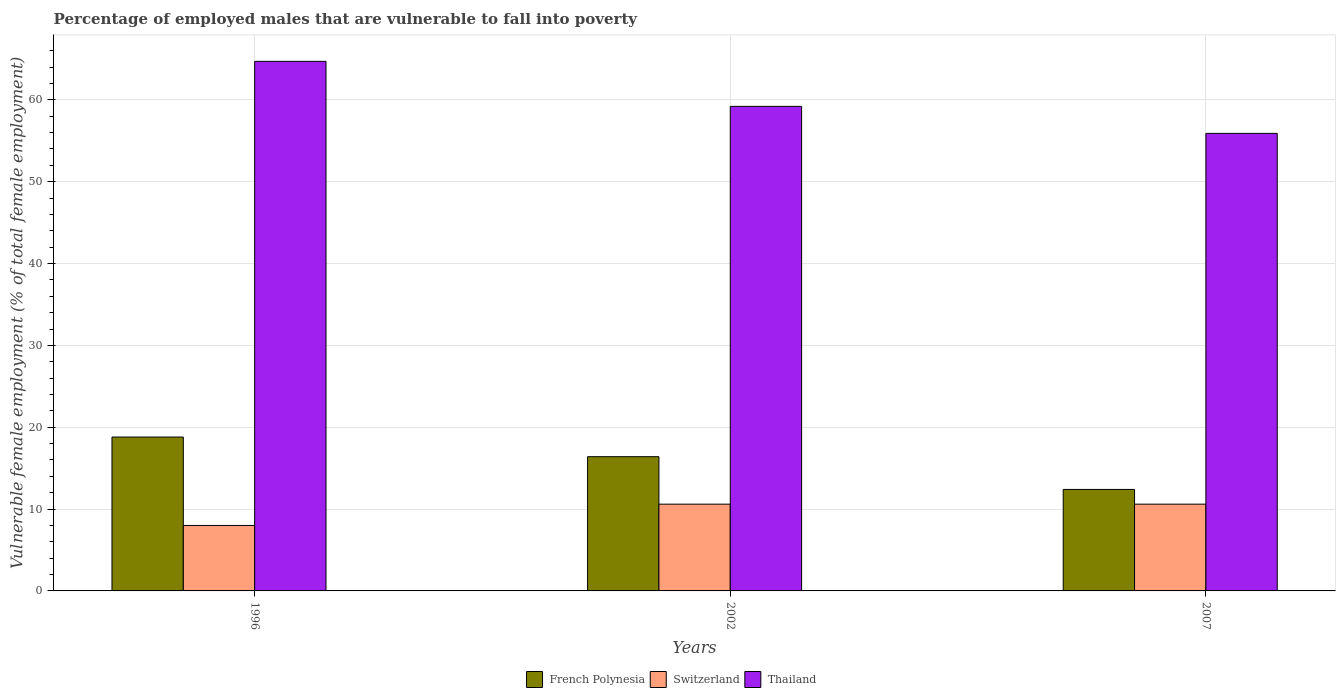How many different coloured bars are there?
Your answer should be very brief. 3. How many bars are there on the 3rd tick from the left?
Offer a very short reply. 3. What is the percentage of employed males who are vulnerable to fall into poverty in French Polynesia in 2002?
Provide a short and direct response. 16.4. Across all years, what is the maximum percentage of employed males who are vulnerable to fall into poverty in Thailand?
Your answer should be very brief. 64.7. Across all years, what is the minimum percentage of employed males who are vulnerable to fall into poverty in French Polynesia?
Your answer should be very brief. 12.4. In which year was the percentage of employed males who are vulnerable to fall into poverty in Thailand maximum?
Provide a succinct answer. 1996. In which year was the percentage of employed males who are vulnerable to fall into poverty in Thailand minimum?
Your answer should be compact. 2007. What is the total percentage of employed males who are vulnerable to fall into poverty in Switzerland in the graph?
Ensure brevity in your answer.  29.2. What is the difference between the percentage of employed males who are vulnerable to fall into poverty in French Polynesia in 1996 and that in 2002?
Make the answer very short. 2.4. What is the difference between the percentage of employed males who are vulnerable to fall into poverty in Switzerland in 2007 and the percentage of employed males who are vulnerable to fall into poverty in French Polynesia in 2002?
Offer a terse response. -5.8. What is the average percentage of employed males who are vulnerable to fall into poverty in Switzerland per year?
Offer a terse response. 9.73. In the year 1996, what is the difference between the percentage of employed males who are vulnerable to fall into poverty in Thailand and percentage of employed males who are vulnerable to fall into poverty in French Polynesia?
Make the answer very short. 45.9. In how many years, is the percentage of employed males who are vulnerable to fall into poverty in Switzerland greater than 52 %?
Offer a terse response. 0. What is the ratio of the percentage of employed males who are vulnerable to fall into poverty in French Polynesia in 1996 to that in 2002?
Provide a short and direct response. 1.15. Is the percentage of employed males who are vulnerable to fall into poverty in Thailand in 1996 less than that in 2007?
Provide a succinct answer. No. Is the difference between the percentage of employed males who are vulnerable to fall into poverty in Thailand in 1996 and 2007 greater than the difference between the percentage of employed males who are vulnerable to fall into poverty in French Polynesia in 1996 and 2007?
Offer a very short reply. Yes. What is the difference between the highest and the second highest percentage of employed males who are vulnerable to fall into poverty in Switzerland?
Make the answer very short. 0. What is the difference between the highest and the lowest percentage of employed males who are vulnerable to fall into poverty in French Polynesia?
Provide a succinct answer. 6.4. In how many years, is the percentage of employed males who are vulnerable to fall into poverty in Thailand greater than the average percentage of employed males who are vulnerable to fall into poverty in Thailand taken over all years?
Provide a short and direct response. 1. What does the 1st bar from the left in 2007 represents?
Your response must be concise. French Polynesia. What does the 3rd bar from the right in 1996 represents?
Give a very brief answer. French Polynesia. Does the graph contain any zero values?
Offer a terse response. No. Does the graph contain grids?
Give a very brief answer. Yes. How many legend labels are there?
Your response must be concise. 3. How are the legend labels stacked?
Offer a very short reply. Horizontal. What is the title of the graph?
Give a very brief answer. Percentage of employed males that are vulnerable to fall into poverty. Does "Bahrain" appear as one of the legend labels in the graph?
Your response must be concise. No. What is the label or title of the X-axis?
Ensure brevity in your answer.  Years. What is the label or title of the Y-axis?
Keep it short and to the point. Vulnerable female employment (% of total female employment). What is the Vulnerable female employment (% of total female employment) in French Polynesia in 1996?
Offer a terse response. 18.8. What is the Vulnerable female employment (% of total female employment) of Switzerland in 1996?
Offer a terse response. 8. What is the Vulnerable female employment (% of total female employment) of Thailand in 1996?
Provide a succinct answer. 64.7. What is the Vulnerable female employment (% of total female employment) in French Polynesia in 2002?
Provide a succinct answer. 16.4. What is the Vulnerable female employment (% of total female employment) of Switzerland in 2002?
Your answer should be very brief. 10.6. What is the Vulnerable female employment (% of total female employment) of Thailand in 2002?
Provide a short and direct response. 59.2. What is the Vulnerable female employment (% of total female employment) of French Polynesia in 2007?
Make the answer very short. 12.4. What is the Vulnerable female employment (% of total female employment) in Switzerland in 2007?
Give a very brief answer. 10.6. What is the Vulnerable female employment (% of total female employment) of Thailand in 2007?
Offer a very short reply. 55.9. Across all years, what is the maximum Vulnerable female employment (% of total female employment) of French Polynesia?
Keep it short and to the point. 18.8. Across all years, what is the maximum Vulnerable female employment (% of total female employment) of Switzerland?
Provide a succinct answer. 10.6. Across all years, what is the maximum Vulnerable female employment (% of total female employment) in Thailand?
Keep it short and to the point. 64.7. Across all years, what is the minimum Vulnerable female employment (% of total female employment) of French Polynesia?
Offer a terse response. 12.4. Across all years, what is the minimum Vulnerable female employment (% of total female employment) of Thailand?
Offer a very short reply. 55.9. What is the total Vulnerable female employment (% of total female employment) in French Polynesia in the graph?
Provide a succinct answer. 47.6. What is the total Vulnerable female employment (% of total female employment) of Switzerland in the graph?
Your answer should be compact. 29.2. What is the total Vulnerable female employment (% of total female employment) of Thailand in the graph?
Offer a very short reply. 179.8. What is the difference between the Vulnerable female employment (% of total female employment) in French Polynesia in 1996 and that in 2002?
Your response must be concise. 2.4. What is the difference between the Vulnerable female employment (% of total female employment) in Thailand in 1996 and that in 2002?
Provide a short and direct response. 5.5. What is the difference between the Vulnerable female employment (% of total female employment) in French Polynesia in 1996 and that in 2007?
Make the answer very short. 6.4. What is the difference between the Vulnerable female employment (% of total female employment) of Switzerland in 1996 and that in 2007?
Your answer should be very brief. -2.6. What is the difference between the Vulnerable female employment (% of total female employment) in French Polynesia in 2002 and that in 2007?
Offer a terse response. 4. What is the difference between the Vulnerable female employment (% of total female employment) in Switzerland in 2002 and that in 2007?
Your answer should be very brief. 0. What is the difference between the Vulnerable female employment (% of total female employment) in Thailand in 2002 and that in 2007?
Give a very brief answer. 3.3. What is the difference between the Vulnerable female employment (% of total female employment) of French Polynesia in 1996 and the Vulnerable female employment (% of total female employment) of Switzerland in 2002?
Ensure brevity in your answer.  8.2. What is the difference between the Vulnerable female employment (% of total female employment) in French Polynesia in 1996 and the Vulnerable female employment (% of total female employment) in Thailand in 2002?
Your answer should be very brief. -40.4. What is the difference between the Vulnerable female employment (% of total female employment) of Switzerland in 1996 and the Vulnerable female employment (% of total female employment) of Thailand in 2002?
Give a very brief answer. -51.2. What is the difference between the Vulnerable female employment (% of total female employment) of French Polynesia in 1996 and the Vulnerable female employment (% of total female employment) of Switzerland in 2007?
Keep it short and to the point. 8.2. What is the difference between the Vulnerable female employment (% of total female employment) of French Polynesia in 1996 and the Vulnerable female employment (% of total female employment) of Thailand in 2007?
Give a very brief answer. -37.1. What is the difference between the Vulnerable female employment (% of total female employment) of Switzerland in 1996 and the Vulnerable female employment (% of total female employment) of Thailand in 2007?
Your response must be concise. -47.9. What is the difference between the Vulnerable female employment (% of total female employment) in French Polynesia in 2002 and the Vulnerable female employment (% of total female employment) in Thailand in 2007?
Ensure brevity in your answer.  -39.5. What is the difference between the Vulnerable female employment (% of total female employment) in Switzerland in 2002 and the Vulnerable female employment (% of total female employment) in Thailand in 2007?
Keep it short and to the point. -45.3. What is the average Vulnerable female employment (% of total female employment) in French Polynesia per year?
Your answer should be very brief. 15.87. What is the average Vulnerable female employment (% of total female employment) of Switzerland per year?
Provide a succinct answer. 9.73. What is the average Vulnerable female employment (% of total female employment) in Thailand per year?
Your answer should be compact. 59.93. In the year 1996, what is the difference between the Vulnerable female employment (% of total female employment) in French Polynesia and Vulnerable female employment (% of total female employment) in Thailand?
Ensure brevity in your answer.  -45.9. In the year 1996, what is the difference between the Vulnerable female employment (% of total female employment) of Switzerland and Vulnerable female employment (% of total female employment) of Thailand?
Offer a terse response. -56.7. In the year 2002, what is the difference between the Vulnerable female employment (% of total female employment) of French Polynesia and Vulnerable female employment (% of total female employment) of Switzerland?
Provide a succinct answer. 5.8. In the year 2002, what is the difference between the Vulnerable female employment (% of total female employment) in French Polynesia and Vulnerable female employment (% of total female employment) in Thailand?
Ensure brevity in your answer.  -42.8. In the year 2002, what is the difference between the Vulnerable female employment (% of total female employment) in Switzerland and Vulnerable female employment (% of total female employment) in Thailand?
Your response must be concise. -48.6. In the year 2007, what is the difference between the Vulnerable female employment (% of total female employment) in French Polynesia and Vulnerable female employment (% of total female employment) in Thailand?
Provide a short and direct response. -43.5. In the year 2007, what is the difference between the Vulnerable female employment (% of total female employment) in Switzerland and Vulnerable female employment (% of total female employment) in Thailand?
Give a very brief answer. -45.3. What is the ratio of the Vulnerable female employment (% of total female employment) of French Polynesia in 1996 to that in 2002?
Make the answer very short. 1.15. What is the ratio of the Vulnerable female employment (% of total female employment) in Switzerland in 1996 to that in 2002?
Offer a terse response. 0.75. What is the ratio of the Vulnerable female employment (% of total female employment) of Thailand in 1996 to that in 2002?
Ensure brevity in your answer.  1.09. What is the ratio of the Vulnerable female employment (% of total female employment) of French Polynesia in 1996 to that in 2007?
Your response must be concise. 1.52. What is the ratio of the Vulnerable female employment (% of total female employment) in Switzerland in 1996 to that in 2007?
Provide a short and direct response. 0.75. What is the ratio of the Vulnerable female employment (% of total female employment) in Thailand in 1996 to that in 2007?
Keep it short and to the point. 1.16. What is the ratio of the Vulnerable female employment (% of total female employment) in French Polynesia in 2002 to that in 2007?
Offer a very short reply. 1.32. What is the ratio of the Vulnerable female employment (% of total female employment) in Thailand in 2002 to that in 2007?
Offer a very short reply. 1.06. What is the difference between the highest and the second highest Vulnerable female employment (% of total female employment) in Switzerland?
Offer a very short reply. 0. What is the difference between the highest and the second highest Vulnerable female employment (% of total female employment) of Thailand?
Provide a short and direct response. 5.5. 